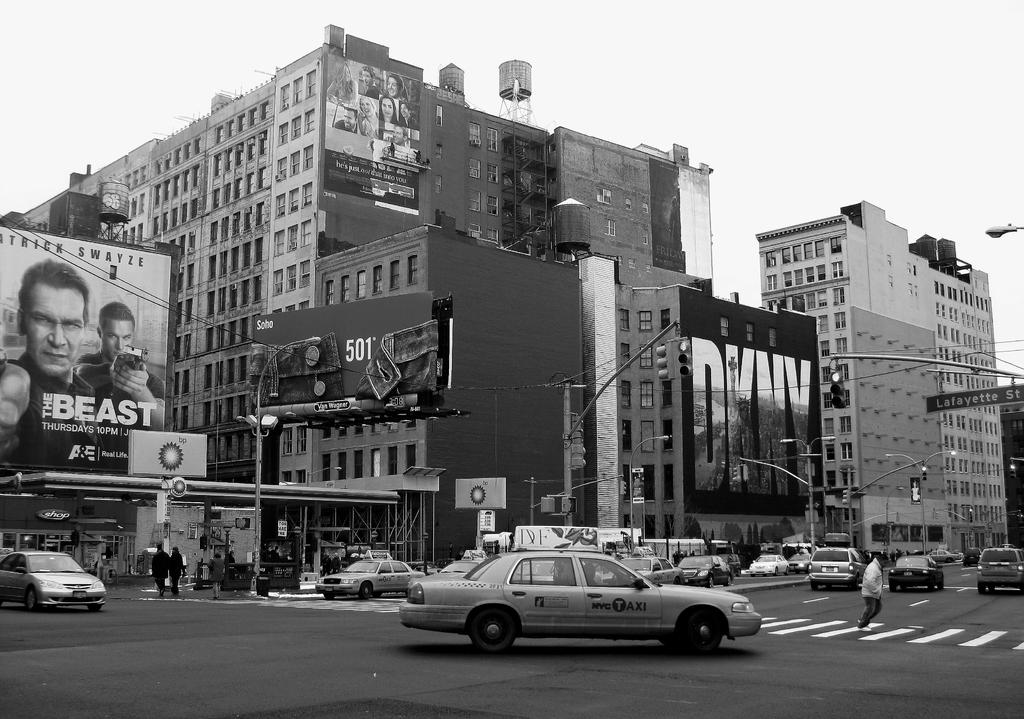Provide a one-sentence caption for the provided image. A large advertisement for the television show The Beast is displayed on a New York street. 